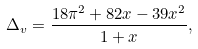Convert formula to latex. <formula><loc_0><loc_0><loc_500><loc_500>\Delta _ { v } = \frac { 1 8 \pi ^ { 2 } + 8 2 x - 3 9 x ^ { 2 } } { 1 + x } ,</formula> 